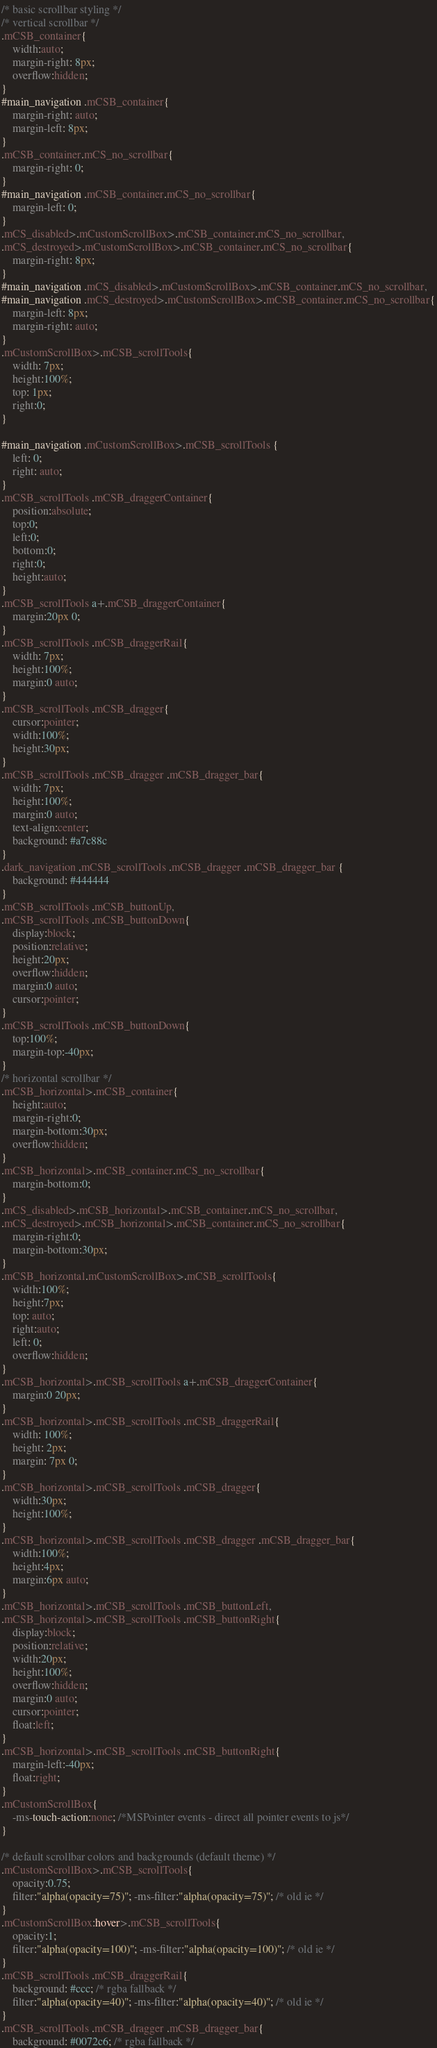<code> <loc_0><loc_0><loc_500><loc_500><_CSS_>/* basic scrollbar styling */
/* vertical scrollbar */
.mCSB_container{
	width:auto;
	margin-right: 8px;
	overflow:hidden;
}
#main_navigation .mCSB_container{
	margin-right: auto;
	margin-left: 8px;
}
.mCSB_container.mCS_no_scrollbar{
	margin-right: 0;
}
#main_navigation .mCSB_container.mCS_no_scrollbar{
	margin-left: 0;
}
.mCS_disabled>.mCustomScrollBox>.mCSB_container.mCS_no_scrollbar,
.mCS_destroyed>.mCustomScrollBox>.mCSB_container.mCS_no_scrollbar{
	margin-right: 8px;
} 
#main_navigation .mCS_disabled>.mCustomScrollBox>.mCSB_container.mCS_no_scrollbar,
#main_navigation .mCS_destroyed>.mCustomScrollBox>.mCSB_container.mCS_no_scrollbar{
	margin-left: 8px;
	margin-right: auto;
}
.mCustomScrollBox>.mCSB_scrollTools{
	width: 7px;
	height:100%;
	top: 1px;
	right:0;
}

#main_navigation .mCustomScrollBox>.mCSB_scrollTools {
	left: 0;
	right: auto;
}
.mCSB_scrollTools .mCSB_draggerContainer{
	position:absolute;
	top:0;
	left:0;
	bottom:0;
	right:0; 
	height:auto;
}
.mCSB_scrollTools a+.mCSB_draggerContainer{
	margin:20px 0;
}
.mCSB_scrollTools .mCSB_draggerRail{
	width: 7px;
	height:100%;
	margin:0 auto;
}
.mCSB_scrollTools .mCSB_dragger{
	cursor:pointer;
	width:100%;
	height:30px;
}
.mCSB_scrollTools .mCSB_dragger .mCSB_dragger_bar{
	width: 7px;
	height:100%;
	margin:0 auto;
	text-align:center;
	background: #a7c88c
}
.dark_navigation .mCSB_scrollTools .mCSB_dragger .mCSB_dragger_bar {
	background: #444444
}
.mCSB_scrollTools .mCSB_buttonUp,
.mCSB_scrollTools .mCSB_buttonDown{
	display:block;
	position:relative;
	height:20px;
	overflow:hidden;
	margin:0 auto;
	cursor:pointer;
}
.mCSB_scrollTools .mCSB_buttonDown{
	top:100%;
	margin-top:-40px;
}
/* horizontal scrollbar */
.mCSB_horizontal>.mCSB_container{
	height:auto;
	margin-right:0;
	margin-bottom:30px;
	overflow:hidden;
}
.mCSB_horizontal>.mCSB_container.mCS_no_scrollbar{
	margin-bottom:0;
}
.mCS_disabled>.mCSB_horizontal>.mCSB_container.mCS_no_scrollbar,
.mCS_destroyed>.mCSB_horizontal>.mCSB_container.mCS_no_scrollbar{
	margin-right:0;
	margin-bottom:30px;
}
.mCSB_horizontal.mCustomScrollBox>.mCSB_scrollTools{
	width:100%;
	height:7px;
	top: auto;
	right:auto;
	left: 0;
	overflow:hidden;
}
.mCSB_horizontal>.mCSB_scrollTools a+.mCSB_draggerContainer{
	margin:0 20px;
}
.mCSB_horizontal>.mCSB_scrollTools .mCSB_draggerRail{
	width: 100%;
	height: 2px;
	margin: 7px 0;
}
.mCSB_horizontal>.mCSB_scrollTools .mCSB_dragger{
	width:30px;
	height:100%;
}
.mCSB_horizontal>.mCSB_scrollTools .mCSB_dragger .mCSB_dragger_bar{
	width:100%;
	height:4px;
	margin:6px auto;
}
.mCSB_horizontal>.mCSB_scrollTools .mCSB_buttonLeft,
.mCSB_horizontal>.mCSB_scrollTools .mCSB_buttonRight{
	display:block;
	position:relative;
	width:20px;
	height:100%;
	overflow:hidden;
	margin:0 auto;
	cursor:pointer;
	float:left;
}
.mCSB_horizontal>.mCSB_scrollTools .mCSB_buttonRight{
	margin-left:-40px;
	float:right;
}
.mCustomScrollBox{
	-ms-touch-action:none; /*MSPointer events - direct all pointer events to js*/
}

/* default scrollbar colors and backgrounds (default theme) */
.mCustomScrollBox>.mCSB_scrollTools{
	opacity:0.75;
	filter:"alpha(opacity=75)"; -ms-filter:"alpha(opacity=75)"; /* old ie */
}
.mCustomScrollBox:hover>.mCSB_scrollTools{
	opacity:1;
	filter:"alpha(opacity=100)"; -ms-filter:"alpha(opacity=100)"; /* old ie */
}
.mCSB_scrollTools .mCSB_draggerRail{
	background: #ccc; /* rgba fallback */
	filter:"alpha(opacity=40)"; -ms-filter:"alpha(opacity=40)"; /* old ie */
}
.mCSB_scrollTools .mCSB_dragger .mCSB_dragger_bar{
	background: #0072c6; /* rgba fallback */</code> 